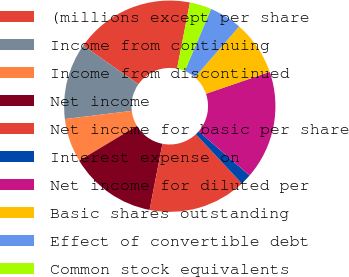Convert chart. <chart><loc_0><loc_0><loc_500><loc_500><pie_chart><fcel>(millions except per share<fcel>Income from continuing<fcel>Income from discontinued<fcel>Net income<fcel>Net income for basic per share<fcel>Interest expense on<fcel>Net income for diluted per<fcel>Basic shares outstanding<fcel>Effect of convertible debt<fcel>Common stock equivalents<nl><fcel>18.33%<fcel>11.67%<fcel>6.67%<fcel>13.33%<fcel>15.0%<fcel>1.67%<fcel>16.66%<fcel>8.33%<fcel>5.0%<fcel>3.34%<nl></chart> 